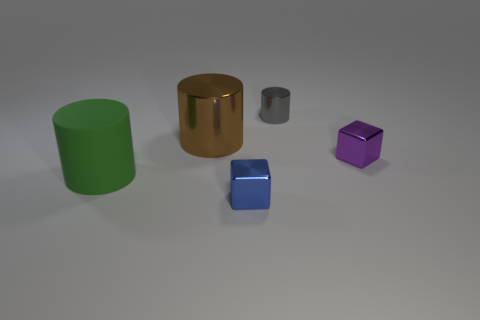The metallic thing that is behind the purple shiny cube and in front of the tiny gray metal cylinder has what shape? The object located behind the purple cube and in front of the small gray cylinder has a cylindrical shape with a shiny golden surface that reflects light. Its cylindrical form is characterized by its circular base and curved side, extending vertically. 